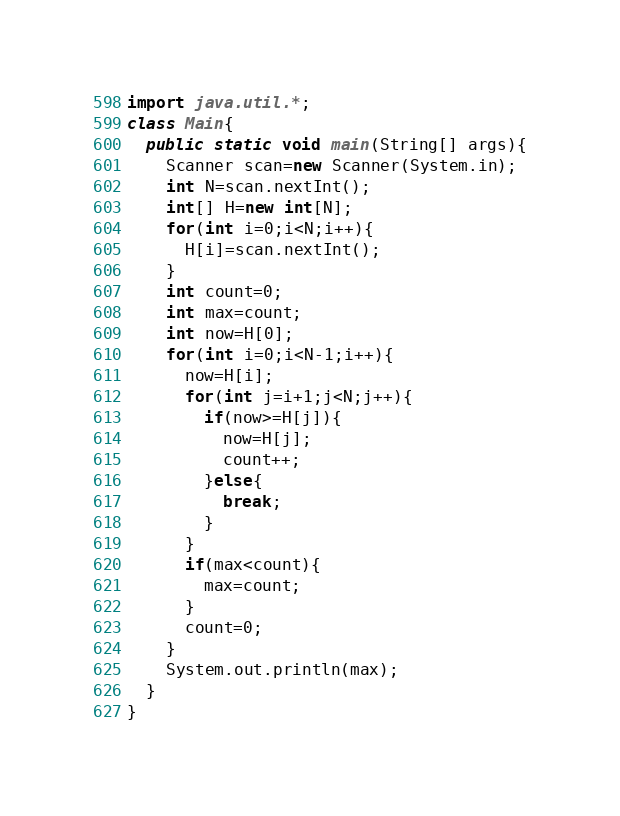Convert code to text. <code><loc_0><loc_0><loc_500><loc_500><_Java_>import java.util.*;
class Main{
  public static void main(String[] args){
    Scanner scan=new Scanner(System.in);
    int N=scan.nextInt();
    int[] H=new int[N];
    for(int i=0;i<N;i++){
      H[i]=scan.nextInt();
    }
    int count=0;
    int max=count;
    int now=H[0];
    for(int i=0;i<N-1;i++){
      now=H[i];
      for(int j=i+1;j<N;j++){
        if(now>=H[j]){
          now=H[j];
          count++;
        }else{
          break;
        }
      }
      if(max<count){
        max=count;
      }
      count=0;
    }
    System.out.println(max);
  }
}</code> 